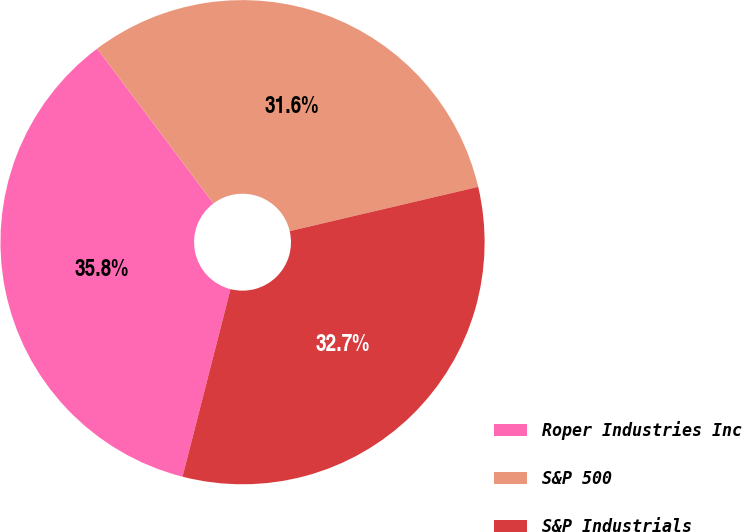Convert chart. <chart><loc_0><loc_0><loc_500><loc_500><pie_chart><fcel>Roper Industries Inc<fcel>S&P 500<fcel>S&P Industrials<nl><fcel>35.76%<fcel>31.58%<fcel>32.66%<nl></chart> 